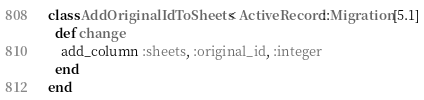<code> <loc_0><loc_0><loc_500><loc_500><_Ruby_>class AddOriginalIdToSheets < ActiveRecord::Migration[5.1]
  def change
    add_column :sheets, :original_id, :integer
  end
end
</code> 